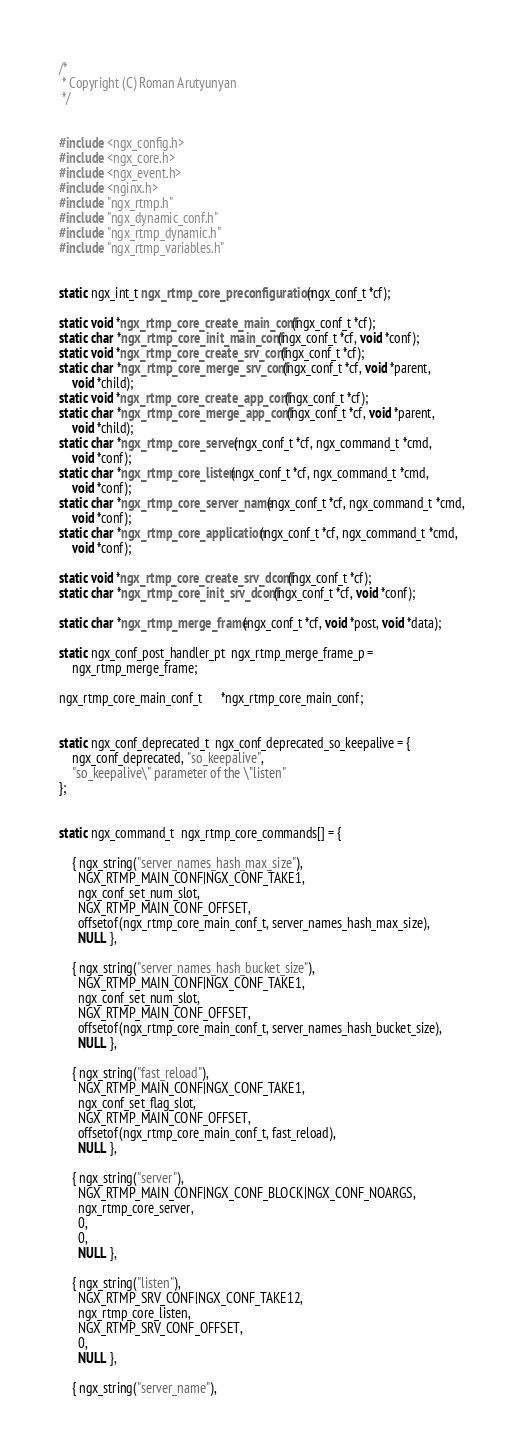Convert code to text. <code><loc_0><loc_0><loc_500><loc_500><_C_>
/*
 * Copyright (C) Roman Arutyunyan
 */


#include <ngx_config.h>
#include <ngx_core.h>
#include <ngx_event.h>
#include <nginx.h>
#include "ngx_rtmp.h"
#include "ngx_dynamic_conf.h"
#include "ngx_rtmp_dynamic.h"
#include "ngx_rtmp_variables.h"


static ngx_int_t ngx_rtmp_core_preconfiguration(ngx_conf_t *cf);

static void *ngx_rtmp_core_create_main_conf(ngx_conf_t *cf);
static char *ngx_rtmp_core_init_main_conf(ngx_conf_t *cf, void *conf);
static void *ngx_rtmp_core_create_srv_conf(ngx_conf_t *cf);
static char *ngx_rtmp_core_merge_srv_conf(ngx_conf_t *cf, void *parent,
    void *child);
static void *ngx_rtmp_core_create_app_conf(ngx_conf_t *cf);
static char *ngx_rtmp_core_merge_app_conf(ngx_conf_t *cf, void *parent,
    void *child);
static char *ngx_rtmp_core_server(ngx_conf_t *cf, ngx_command_t *cmd,
    void *conf);
static char *ngx_rtmp_core_listen(ngx_conf_t *cf, ngx_command_t *cmd,
    void *conf);
static char *ngx_rtmp_core_server_name(ngx_conf_t *cf, ngx_command_t *cmd,
    void *conf);
static char *ngx_rtmp_core_application(ngx_conf_t *cf, ngx_command_t *cmd,
    void *conf);

static void *ngx_rtmp_core_create_srv_dconf(ngx_conf_t *cf);
static char *ngx_rtmp_core_init_srv_dconf(ngx_conf_t *cf, void *conf);

static char *ngx_rtmp_merge_frame(ngx_conf_t *cf, void *post, void *data);

static ngx_conf_post_handler_pt  ngx_rtmp_merge_frame_p =
    ngx_rtmp_merge_frame;

ngx_rtmp_core_main_conf_t      *ngx_rtmp_core_main_conf;


static ngx_conf_deprecated_t  ngx_conf_deprecated_so_keepalive = {
    ngx_conf_deprecated, "so_keepalive",
    "so_keepalive\" parameter of the \"listen"
};


static ngx_command_t  ngx_rtmp_core_commands[] = {

    { ngx_string("server_names_hash_max_size"),
      NGX_RTMP_MAIN_CONF|NGX_CONF_TAKE1,
      ngx_conf_set_num_slot,
      NGX_RTMP_MAIN_CONF_OFFSET,
      offsetof(ngx_rtmp_core_main_conf_t, server_names_hash_max_size),
      NULL },

    { ngx_string("server_names_hash_bucket_size"),
      NGX_RTMP_MAIN_CONF|NGX_CONF_TAKE1,
      ngx_conf_set_num_slot,
      NGX_RTMP_MAIN_CONF_OFFSET,
      offsetof(ngx_rtmp_core_main_conf_t, server_names_hash_bucket_size),
      NULL },

    { ngx_string("fast_reload"),
      NGX_RTMP_MAIN_CONF|NGX_CONF_TAKE1,
      ngx_conf_set_flag_slot,
      NGX_RTMP_MAIN_CONF_OFFSET,
      offsetof(ngx_rtmp_core_main_conf_t, fast_reload),
      NULL },

    { ngx_string("server"),
      NGX_RTMP_MAIN_CONF|NGX_CONF_BLOCK|NGX_CONF_NOARGS,
      ngx_rtmp_core_server,
      0,
      0,
      NULL },

    { ngx_string("listen"),
      NGX_RTMP_SRV_CONF|NGX_CONF_TAKE12,
      ngx_rtmp_core_listen,
      NGX_RTMP_SRV_CONF_OFFSET,
      0,
      NULL },

    { ngx_string("server_name"),</code> 